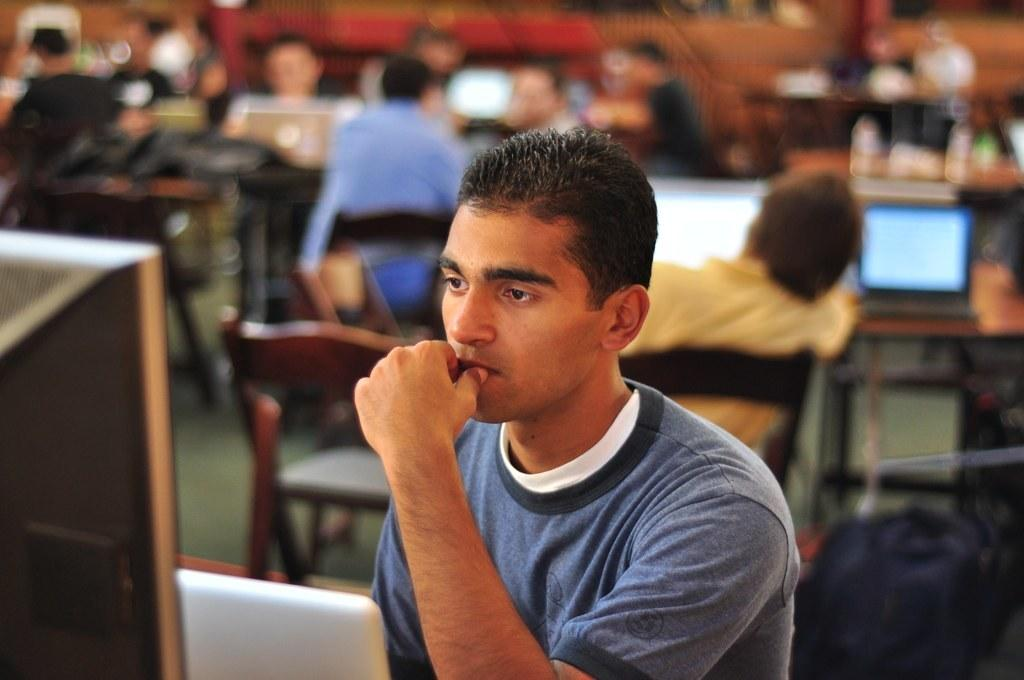What are the people in the image doing? The people in the image are seated on chairs. What electronic devices can be seen in the image? There are monitors and laptops on tables in the image. What month is depicted in the image? There is no specific month depicted in the image; it does not show any seasonal or time-related elements. 